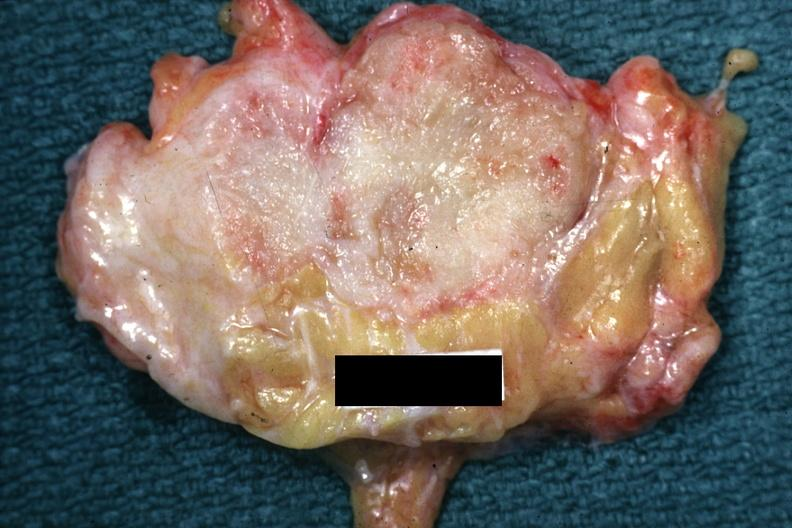what is present?
Answer the question using a single word or phrase. Breast 